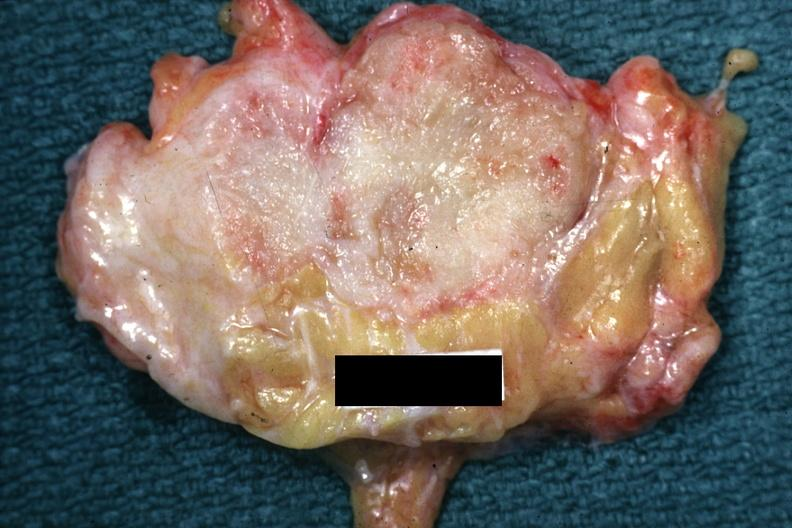what is present?
Answer the question using a single word or phrase. Breast 